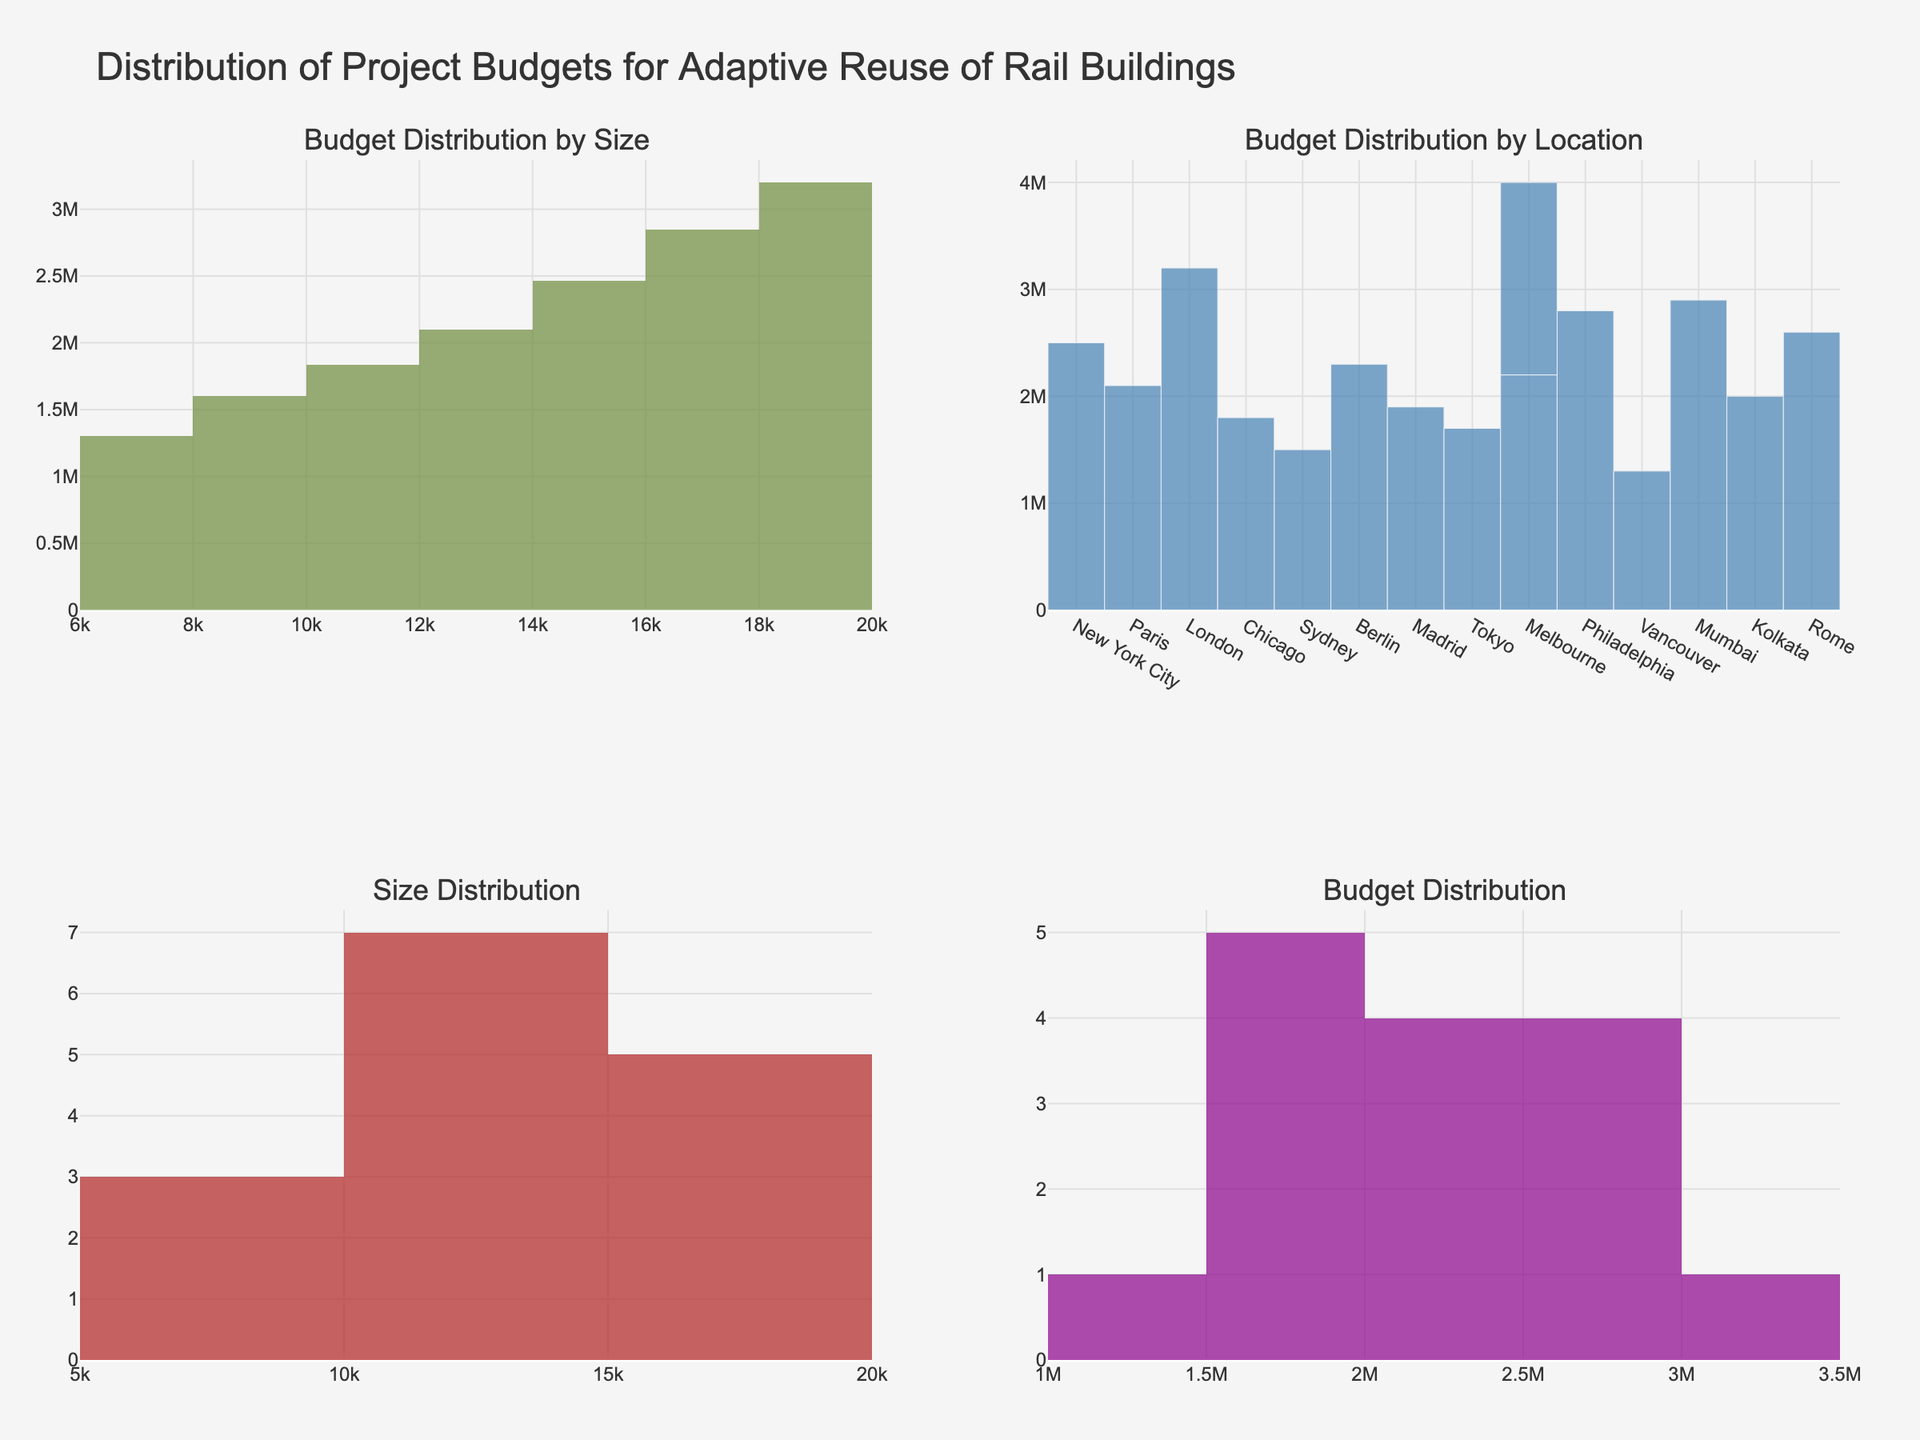What is the title of the figure? The title is usually located at the top of the figure and is used to summarize what the figure is about.
Answer: Distribution of Project Budgets for Adaptive Reuse of Rail Buildings What is the average budget for rail building projects of different sizes? To find the average budget for different sizes, refer to the histogram in the "Budget Distribution by Size" subplot, where the average budget is encoded based on size bins.
Answer: Varies by size bins Which location has the highest project budget? Look at the "Budget Distribution by Location" bar chart and identify the bar with the highest value.
Answer: London What is the range of the project sizes in square feet? Look at the x-axis on the "Size Distribution" histogram to find the minimum and maximum values.
Answer: 7,000 to 18,000 sq ft How many locations have a budget over $2,500,000? Check the "Budget Distribution by Location" bar chart and count the number of bars exceeding $2,500,000.
Answer: 2 What is the most common size range for these projects? Look at the "Size Distribution" histogram for the bins with the most counts.
Answer: Bins around 12,000 to 15,000 sq ft Which histogram shows the frequency distribution of project budgets? Identify the histogram labeled "Budget Distribution."
Answer: The bottom right histogram Are there more projects with budgets under $2,000,000 or over $2,000,000? Count the number of bins in the "Budget Distribution" histogram that fall under and over $2,000,000, respectively.
Answer: Under $2,000,000 What location has the lowest budget, and what is that budget? Look at the "Budget Distribution by Location" bar chart for the shortest bar and note its value and corresponding location.
Answer: Vancouver, $1,300,000 How does the size of a project relate to its budget on average? Refer to the "Budget Distribution by Size" subplot to observe the relationship between size bins and average budget.
Answer: Larger projects generally have higher average budgets 